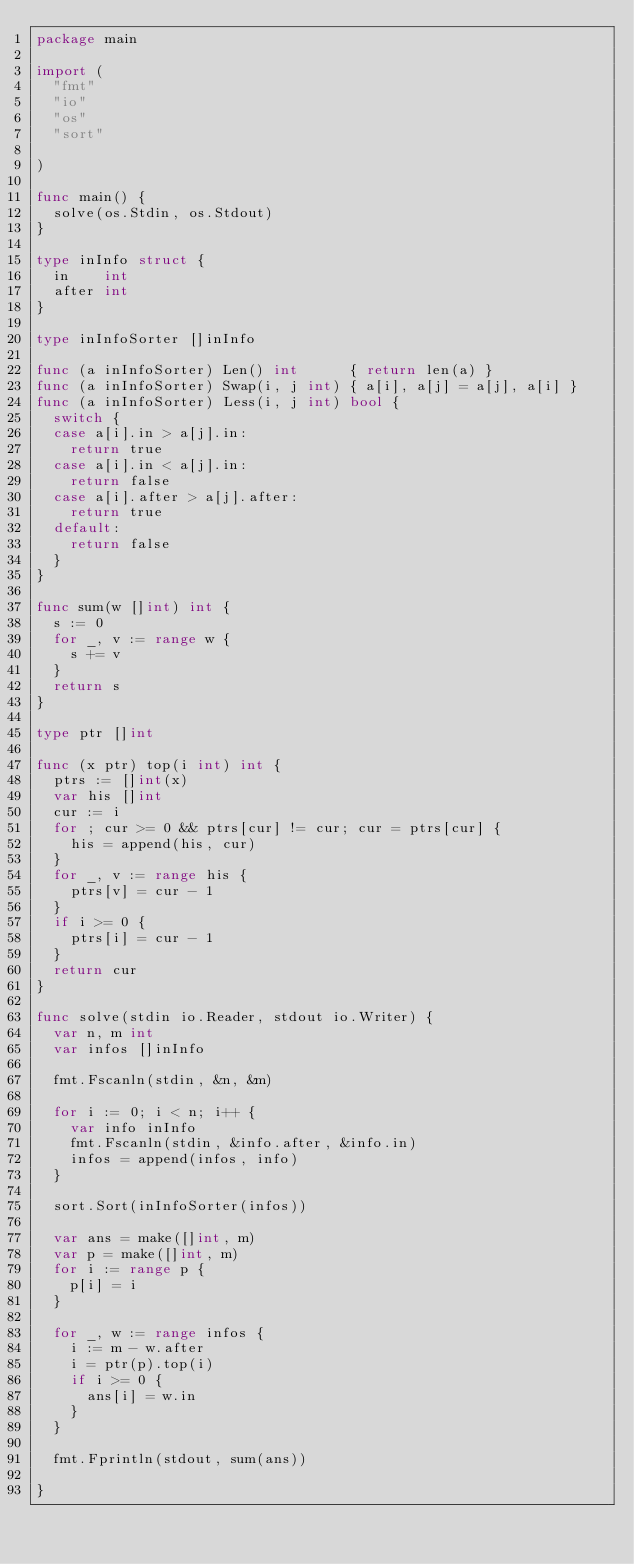<code> <loc_0><loc_0><loc_500><loc_500><_Go_>package main

import (
	"fmt"
	"io"
	"os"
	"sort"

)

func main() {
	solve(os.Stdin, os.Stdout)
}

type inInfo struct {
	in    int
	after int
}

type inInfoSorter []inInfo

func (a inInfoSorter) Len() int      { return len(a) }
func (a inInfoSorter) Swap(i, j int) { a[i], a[j] = a[j], a[i] }
func (a inInfoSorter) Less(i, j int) bool {
	switch {
	case a[i].in > a[j].in:
		return true
	case a[i].in < a[j].in:
		return false
	case a[i].after > a[j].after:
		return true
	default:
		return false
	}
}

func sum(w []int) int {
	s := 0
	for _, v := range w {
		s += v
	}
	return s
}

type ptr []int

func (x ptr) top(i int) int {
	ptrs := []int(x)
	var his []int
	cur := i
	for ; cur >= 0 && ptrs[cur] != cur; cur = ptrs[cur] {
		his = append(his, cur)
	}
	for _, v := range his {
		ptrs[v] = cur - 1
	}
	if i >= 0 {
		ptrs[i] = cur - 1
	}
	return cur
}

func solve(stdin io.Reader, stdout io.Writer) {
	var n, m int
	var infos []inInfo

	fmt.Fscanln(stdin, &n, &m)

	for i := 0; i < n; i++ {
		var info inInfo
		fmt.Fscanln(stdin, &info.after, &info.in)
		infos = append(infos, info)
	}

	sort.Sort(inInfoSorter(infos))

	var ans = make([]int, m)
	var p = make([]int, m)
	for i := range p {
		p[i] = i
	}

	for _, w := range infos {
		i := m - w.after
		i = ptr(p).top(i)
		if i >= 0 {
			ans[i] = w.in
		}
	}

	fmt.Fprintln(stdout, sum(ans))

}

</code> 